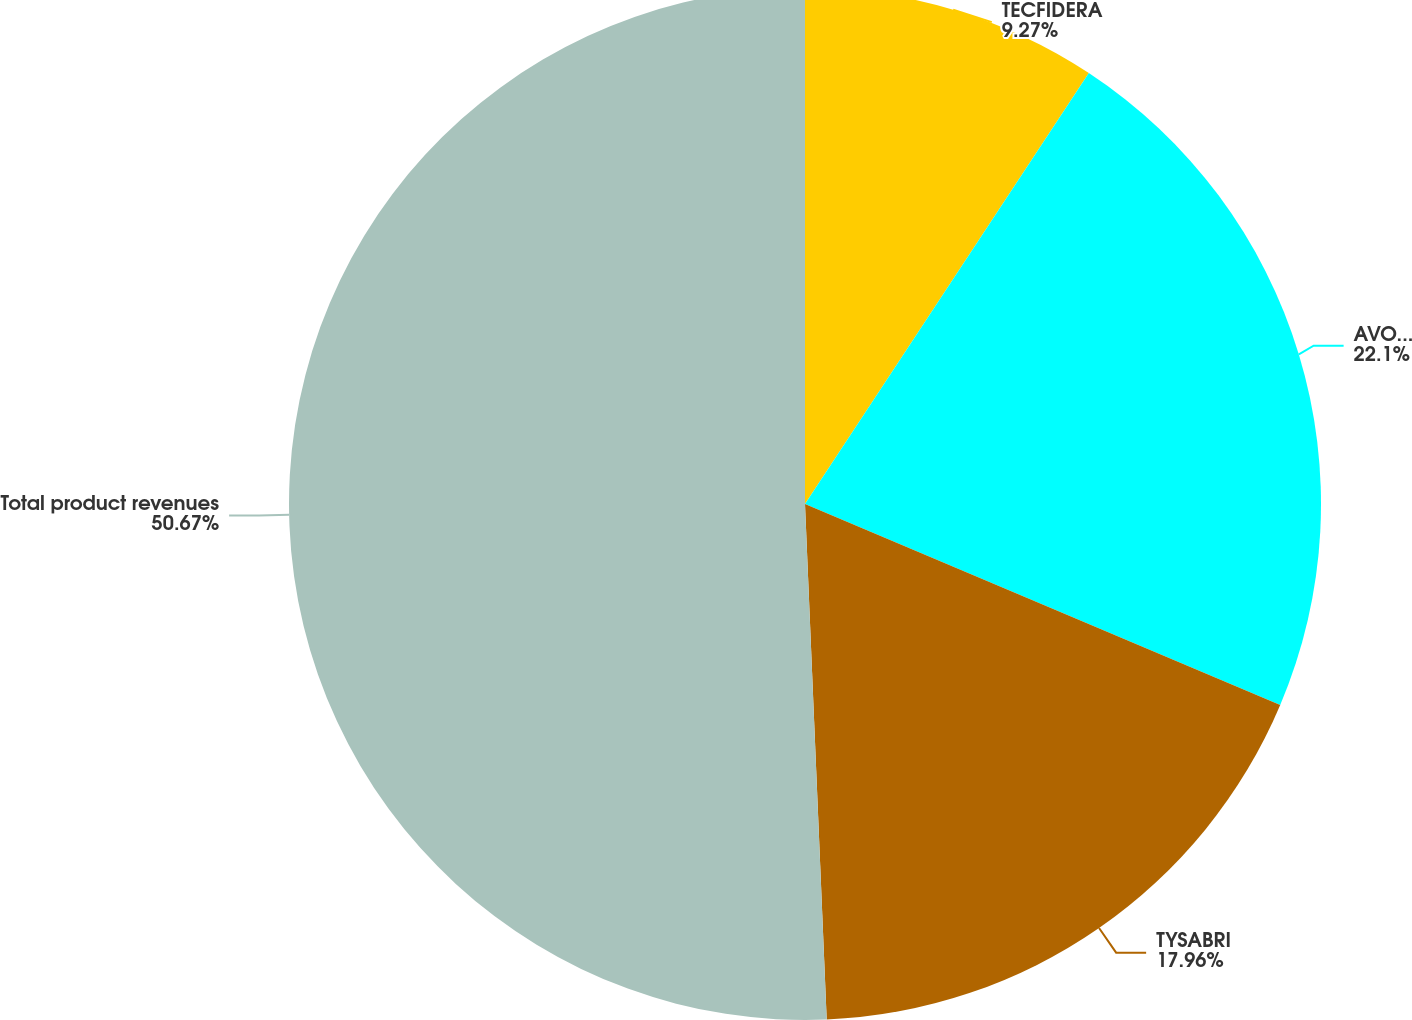<chart> <loc_0><loc_0><loc_500><loc_500><pie_chart><fcel>TECFIDERA<fcel>AVONEX<fcel>TYSABRI<fcel>Total product revenues<nl><fcel>9.27%<fcel>22.1%<fcel>17.96%<fcel>50.67%<nl></chart> 